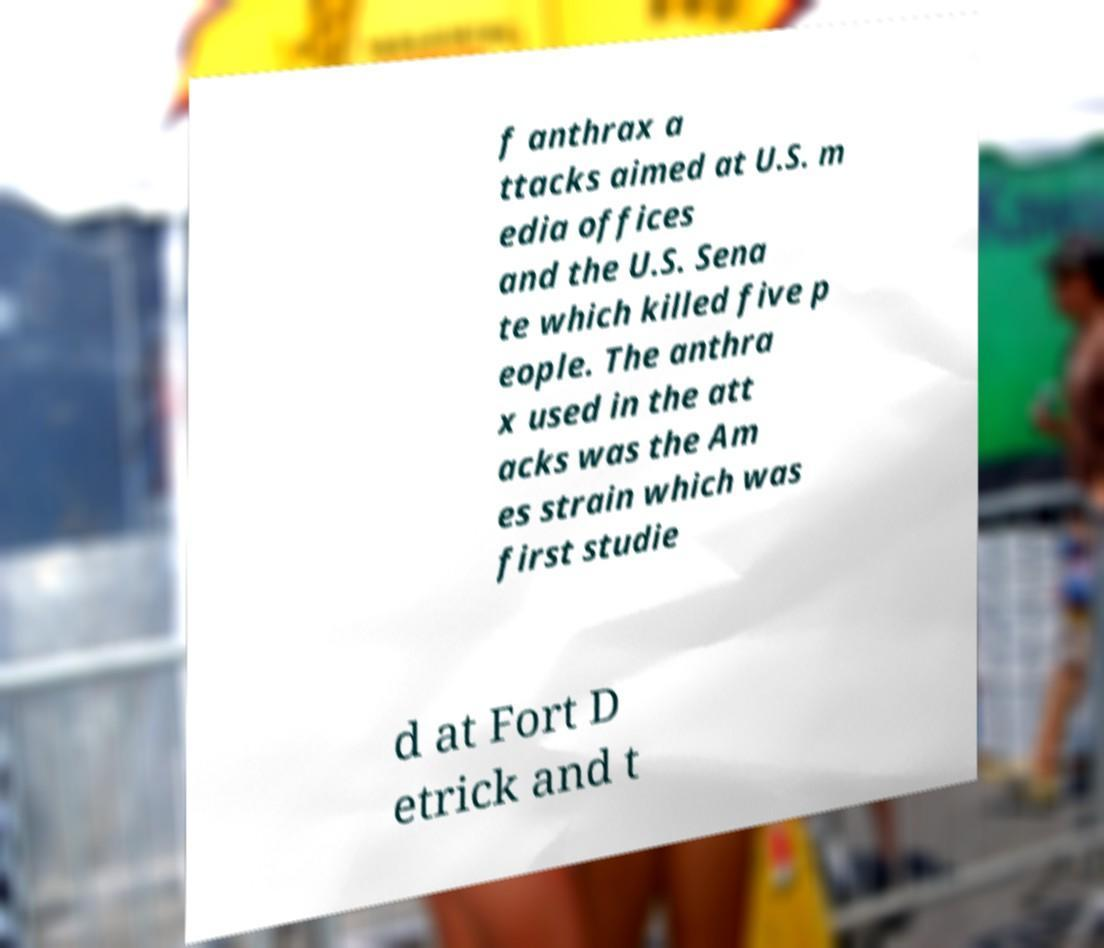What messages or text are displayed in this image? I need them in a readable, typed format. f anthrax a ttacks aimed at U.S. m edia offices and the U.S. Sena te which killed five p eople. The anthra x used in the att acks was the Am es strain which was first studie d at Fort D etrick and t 